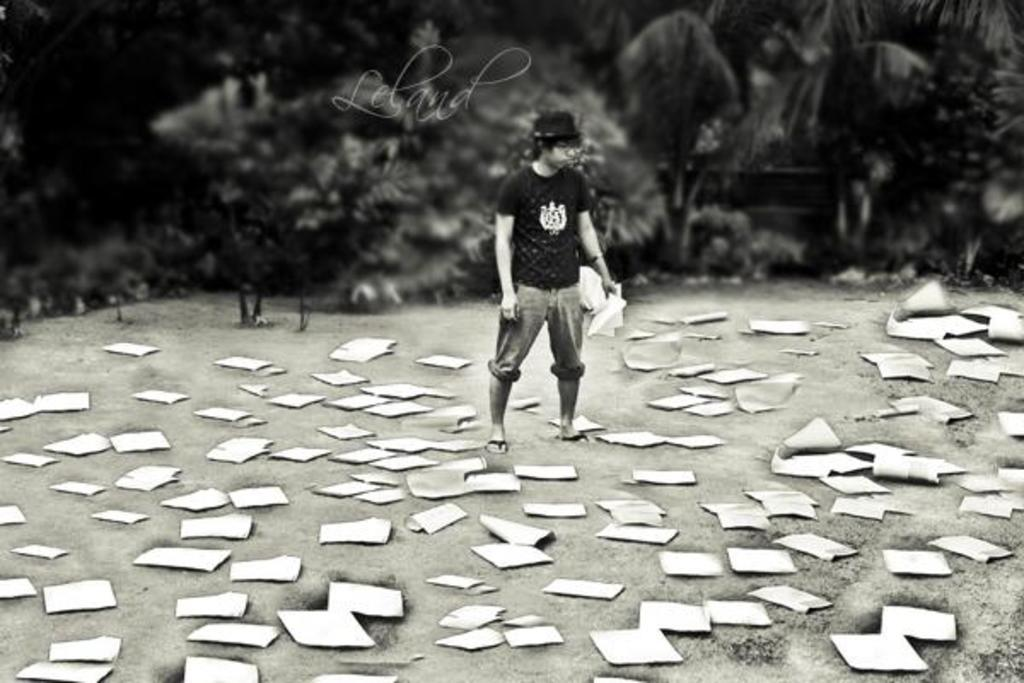Who is present in the image? There is a man in the image. What is the man wearing on his head? The man is wearing a cap. What is the man holding in his hand? The man is holding papers in his hand. What is the man's posture in the image? The man is standing. What is on the ground in front of the man? There are papers on the ground in front of the man. What can be seen in the background of the image? There are trees in the background of the image. How many sisters does the man have in the image? There is no information about the man's sisters in the image. What type of dirt can be seen on the man's shoes in the image? There is no dirt visible on the man's shoes in the image. 